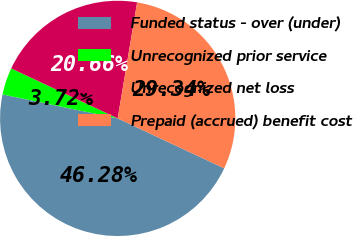<chart> <loc_0><loc_0><loc_500><loc_500><pie_chart><fcel>Funded status - over (under)<fcel>Unrecognized prior service<fcel>Unrecognized net loss<fcel>Prepaid (accrued) benefit cost<nl><fcel>46.28%<fcel>3.72%<fcel>20.66%<fcel>29.34%<nl></chart> 